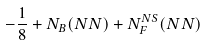Convert formula to latex. <formula><loc_0><loc_0><loc_500><loc_500>- \frac { 1 } { 8 } + N _ { B } ( N N ) + N _ { F } ^ { N S } ( N N )</formula> 